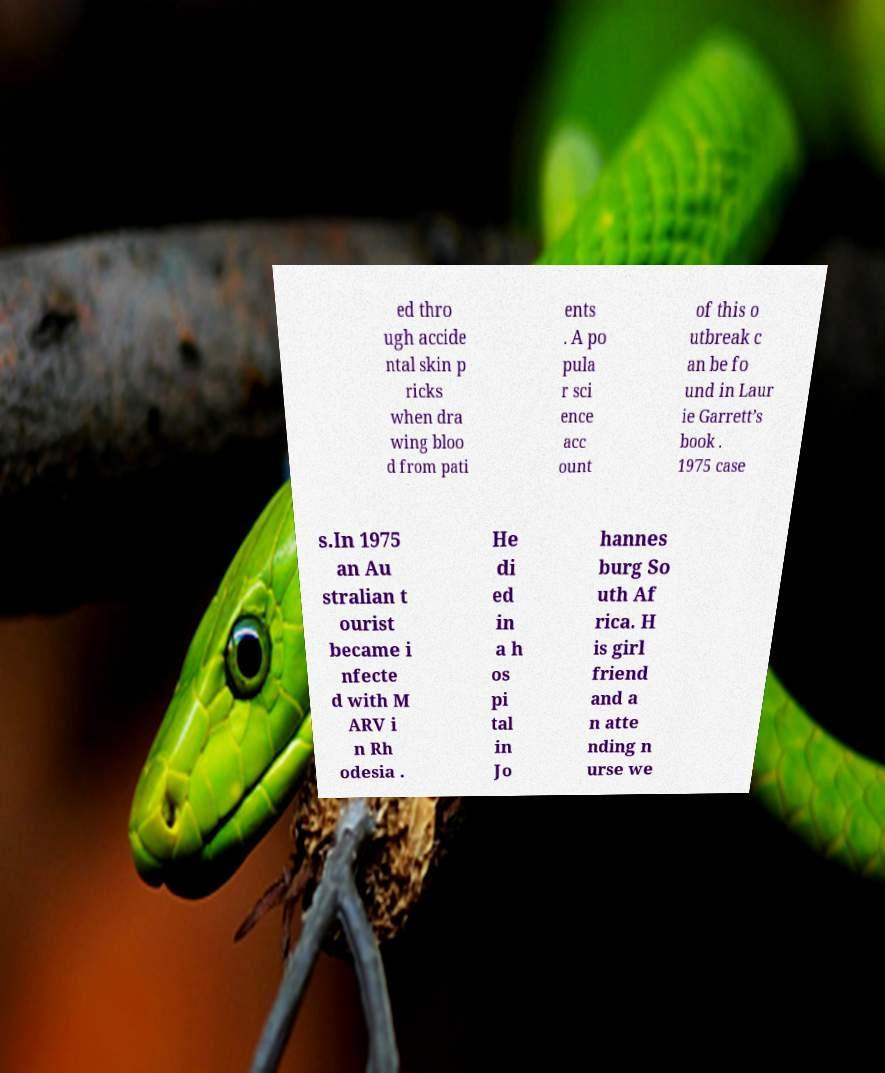Please read and relay the text visible in this image. What does it say? ed thro ugh accide ntal skin p ricks when dra wing bloo d from pati ents . A po pula r sci ence acc ount of this o utbreak c an be fo und in Laur ie Garrett’s book . 1975 case s.In 1975 an Au stralian t ourist became i nfecte d with M ARV i n Rh odesia . He di ed in a h os pi tal in Jo hannes burg So uth Af rica. H is girl friend and a n atte nding n urse we 